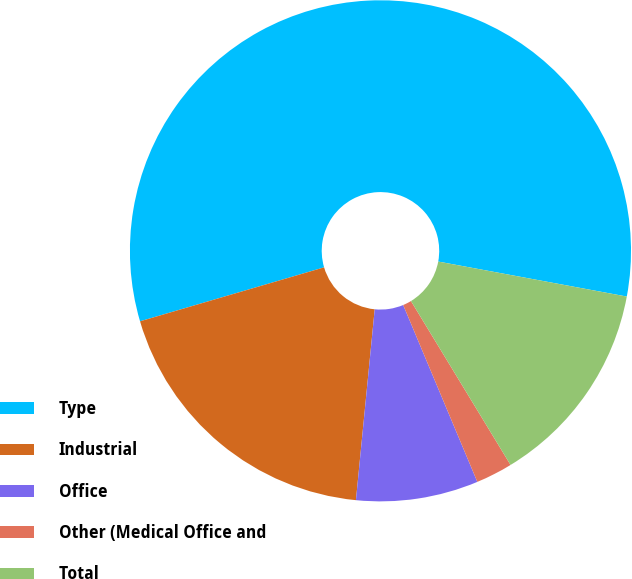Convert chart to OTSL. <chart><loc_0><loc_0><loc_500><loc_500><pie_chart><fcel>Type<fcel>Industrial<fcel>Office<fcel>Other (Medical Office and<fcel>Total<nl><fcel>57.46%<fcel>18.9%<fcel>7.88%<fcel>2.37%<fcel>13.39%<nl></chart> 